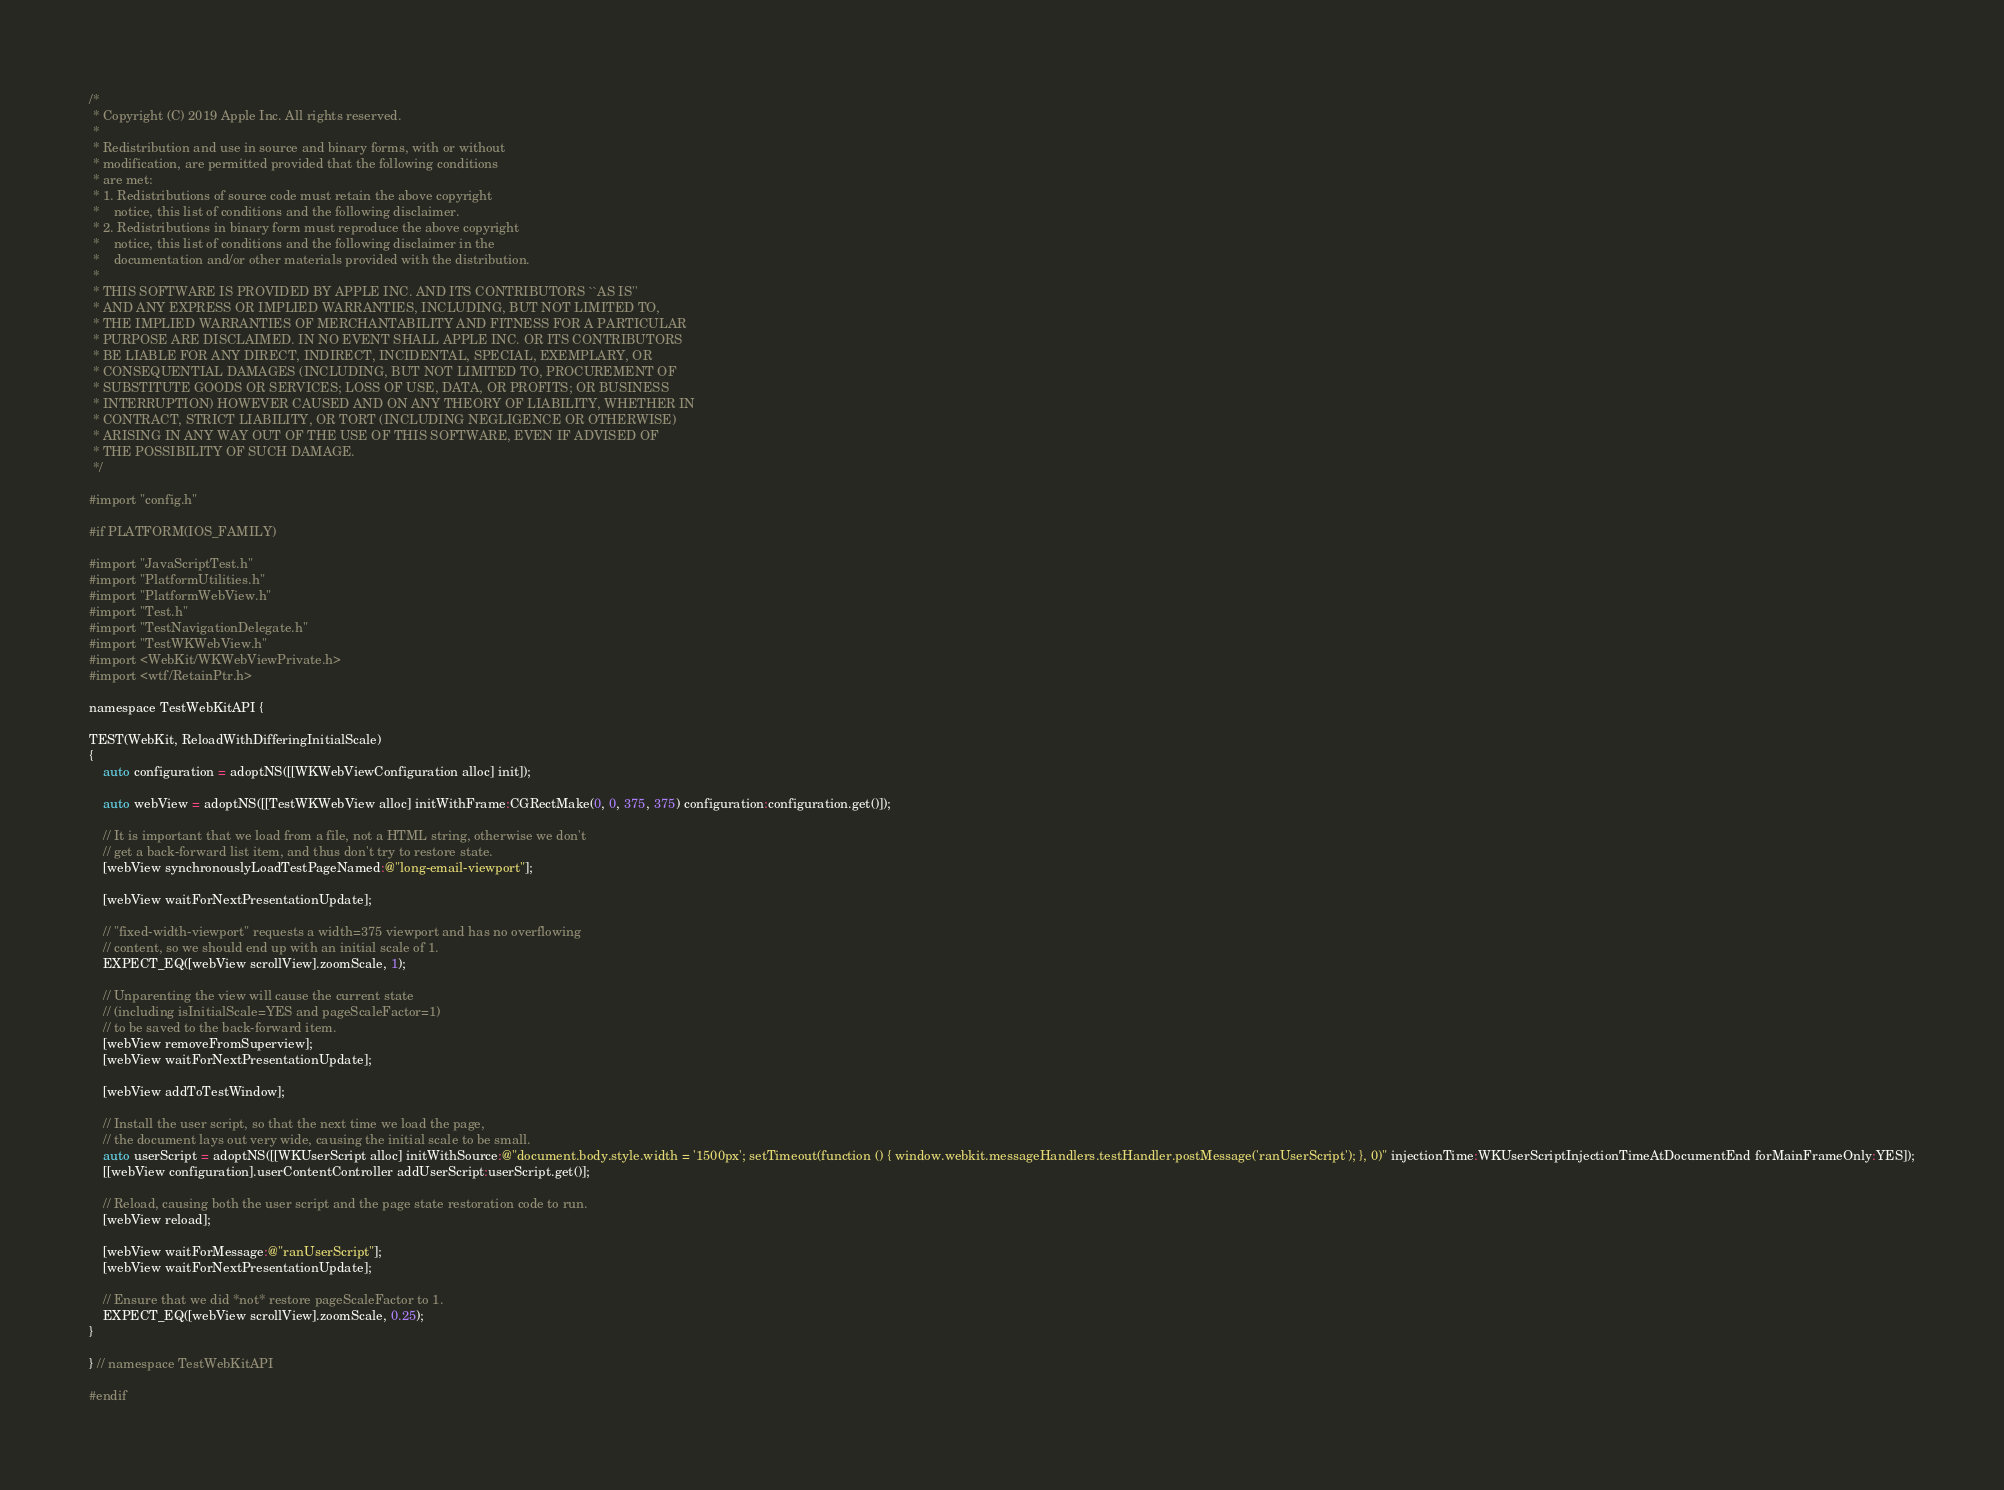<code> <loc_0><loc_0><loc_500><loc_500><_ObjectiveC_>/*
 * Copyright (C) 2019 Apple Inc. All rights reserved.
 *
 * Redistribution and use in source and binary forms, with or without
 * modification, are permitted provided that the following conditions
 * are met:
 * 1. Redistributions of source code must retain the above copyright
 *    notice, this list of conditions and the following disclaimer.
 * 2. Redistributions in binary form must reproduce the above copyright
 *    notice, this list of conditions and the following disclaimer in the
 *    documentation and/or other materials provided with the distribution.
 *
 * THIS SOFTWARE IS PROVIDED BY APPLE INC. AND ITS CONTRIBUTORS ``AS IS''
 * AND ANY EXPRESS OR IMPLIED WARRANTIES, INCLUDING, BUT NOT LIMITED TO,
 * THE IMPLIED WARRANTIES OF MERCHANTABILITY AND FITNESS FOR A PARTICULAR
 * PURPOSE ARE DISCLAIMED. IN NO EVENT SHALL APPLE INC. OR ITS CONTRIBUTORS
 * BE LIABLE FOR ANY DIRECT, INDIRECT, INCIDENTAL, SPECIAL, EXEMPLARY, OR
 * CONSEQUENTIAL DAMAGES (INCLUDING, BUT NOT LIMITED TO, PROCUREMENT OF
 * SUBSTITUTE GOODS OR SERVICES; LOSS OF USE, DATA, OR PROFITS; OR BUSINESS
 * INTERRUPTION) HOWEVER CAUSED AND ON ANY THEORY OF LIABILITY, WHETHER IN
 * CONTRACT, STRICT LIABILITY, OR TORT (INCLUDING NEGLIGENCE OR OTHERWISE)
 * ARISING IN ANY WAY OUT OF THE USE OF THIS SOFTWARE, EVEN IF ADVISED OF
 * THE POSSIBILITY OF SUCH DAMAGE.
 */

#import "config.h"

#if PLATFORM(IOS_FAMILY)

#import "JavaScriptTest.h"
#import "PlatformUtilities.h"
#import "PlatformWebView.h"
#import "Test.h"
#import "TestNavigationDelegate.h"
#import "TestWKWebView.h"
#import <WebKit/WKWebViewPrivate.h>
#import <wtf/RetainPtr.h>

namespace TestWebKitAPI {

TEST(WebKit, ReloadWithDifferingInitialScale)
{
    auto configuration = adoptNS([[WKWebViewConfiguration alloc] init]);

    auto webView = adoptNS([[TestWKWebView alloc] initWithFrame:CGRectMake(0, 0, 375, 375) configuration:configuration.get()]);

    // It is important that we load from a file, not a HTML string, otherwise we don't
    // get a back-forward list item, and thus don't try to restore state.
    [webView synchronouslyLoadTestPageNamed:@"long-email-viewport"];

    [webView waitForNextPresentationUpdate];

    // "fixed-width-viewport" requests a width=375 viewport and has no overflowing
    // content, so we should end up with an initial scale of 1.
    EXPECT_EQ([webView scrollView].zoomScale, 1);

    // Unparenting the view will cause the current state
    // (including isInitialScale=YES and pageScaleFactor=1)
    // to be saved to the back-forward item.
    [webView removeFromSuperview];
    [webView waitForNextPresentationUpdate];

    [webView addToTestWindow];

    // Install the user script, so that the next time we load the page,
    // the document lays out very wide, causing the initial scale to be small.
    auto userScript = adoptNS([[WKUserScript alloc] initWithSource:@"document.body.style.width = '1500px'; setTimeout(function () { window.webkit.messageHandlers.testHandler.postMessage('ranUserScript'); }, 0)" injectionTime:WKUserScriptInjectionTimeAtDocumentEnd forMainFrameOnly:YES]);
    [[webView configuration].userContentController addUserScript:userScript.get()];

    // Reload, causing both the user script and the page state restoration code to run.
    [webView reload];

    [webView waitForMessage:@"ranUserScript"];
    [webView waitForNextPresentationUpdate];

    // Ensure that we did *not* restore pageScaleFactor to 1.
    EXPECT_EQ([webView scrollView].zoomScale, 0.25);
}

} // namespace TestWebKitAPI

#endif
</code> 